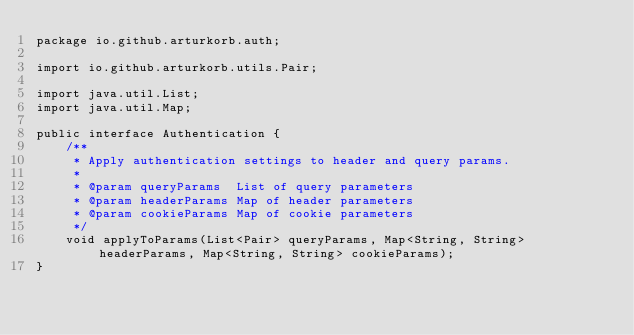Convert code to text. <code><loc_0><loc_0><loc_500><loc_500><_Java_>package io.github.arturkorb.auth;

import io.github.arturkorb.utils.Pair;

import java.util.List;
import java.util.Map;

public interface Authentication {
    /**
     * Apply authentication settings to header and query params.
     *
     * @param queryParams  List of query parameters
     * @param headerParams Map of header parameters
     * @param cookieParams Map of cookie parameters
     */
    void applyToParams(List<Pair> queryParams, Map<String, String> headerParams, Map<String, String> cookieParams);
}
</code> 